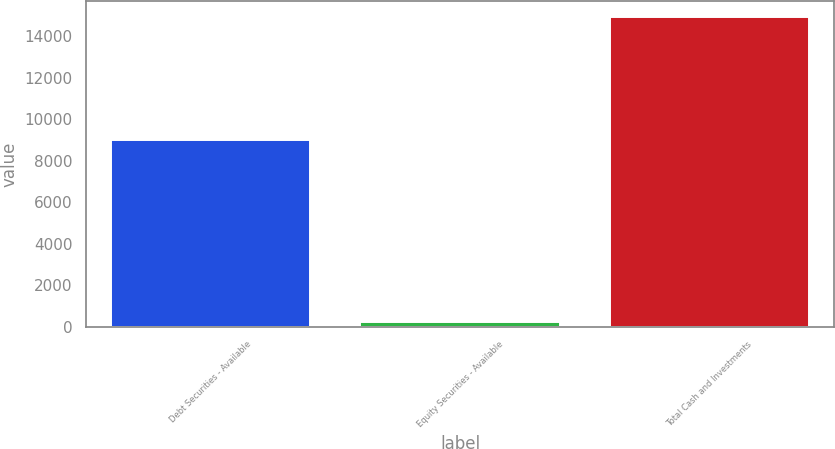Convert chart. <chart><loc_0><loc_0><loc_500><loc_500><bar_chart><fcel>Debt Securities - Available<fcel>Equity Securities - Available<fcel>Total Cash and Investments<nl><fcel>9011<fcel>217<fcel>14930<nl></chart> 